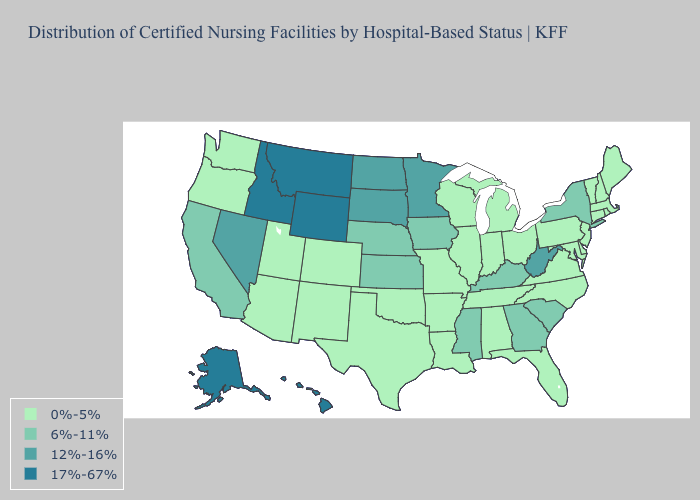Is the legend a continuous bar?
Concise answer only. No. Name the states that have a value in the range 6%-11%?
Answer briefly. California, Georgia, Iowa, Kansas, Kentucky, Mississippi, Nebraska, New York, South Carolina. What is the lowest value in the USA?
Be succinct. 0%-5%. Name the states that have a value in the range 17%-67%?
Quick response, please. Alaska, Hawaii, Idaho, Montana, Wyoming. What is the value of Florida?
Be succinct. 0%-5%. Does New Jersey have the same value as Georgia?
Be succinct. No. Does Louisiana have the highest value in the South?
Keep it brief. No. Does the first symbol in the legend represent the smallest category?
Keep it brief. Yes. Name the states that have a value in the range 17%-67%?
Quick response, please. Alaska, Hawaii, Idaho, Montana, Wyoming. Name the states that have a value in the range 6%-11%?
Give a very brief answer. California, Georgia, Iowa, Kansas, Kentucky, Mississippi, Nebraska, New York, South Carolina. Name the states that have a value in the range 6%-11%?
Keep it brief. California, Georgia, Iowa, Kansas, Kentucky, Mississippi, Nebraska, New York, South Carolina. Among the states that border Oregon , does California have the highest value?
Keep it brief. No. What is the value of Rhode Island?
Quick response, please. 0%-5%. What is the lowest value in the South?
Keep it brief. 0%-5%. Name the states that have a value in the range 17%-67%?
Quick response, please. Alaska, Hawaii, Idaho, Montana, Wyoming. 